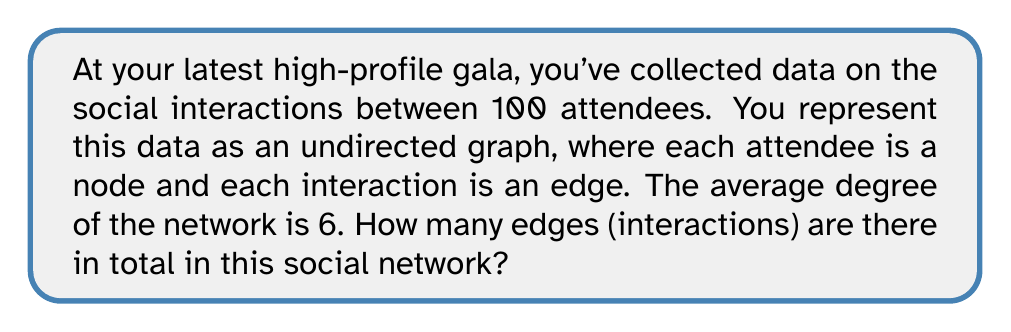Give your solution to this math problem. To solve this problem, we'll use concepts from graph theory in network analysis:

1) In an undirected graph, each edge connects two nodes and contributes to the degree of both nodes.

2) The degree of a node is the number of edges connected to it.

3) The average degree is the sum of all node degrees divided by the number of nodes.

4) Let's define:
   $n$ = number of nodes (attendees)
   $m$ = number of edges (interactions)
   $\bar{d}$ = average degree

5) We know that $n = 100$ and $\bar{d} = 6$

6) In graph theory, there's a fundamental relationship between the sum of degrees and the number of edges:

   $$\sum_{i=1}^n d_i = 2m$$

   This is because each edge contributes to the degree of two nodes.

7) We can express the sum of degrees in terms of average degree:

   $$\sum_{i=1}^n d_i = n\bar{d}$$

8) Combining steps 6 and 7:

   $$n\bar{d} = 2m$$

9) Substituting our known values:

   $$100 * 6 = 2m$$
   $$600 = 2m$$

10) Solving for $m$:

    $$m = 600 / 2 = 300$$

Therefore, there are 300 edges (interactions) in the social network.
Answer: 300 edges 